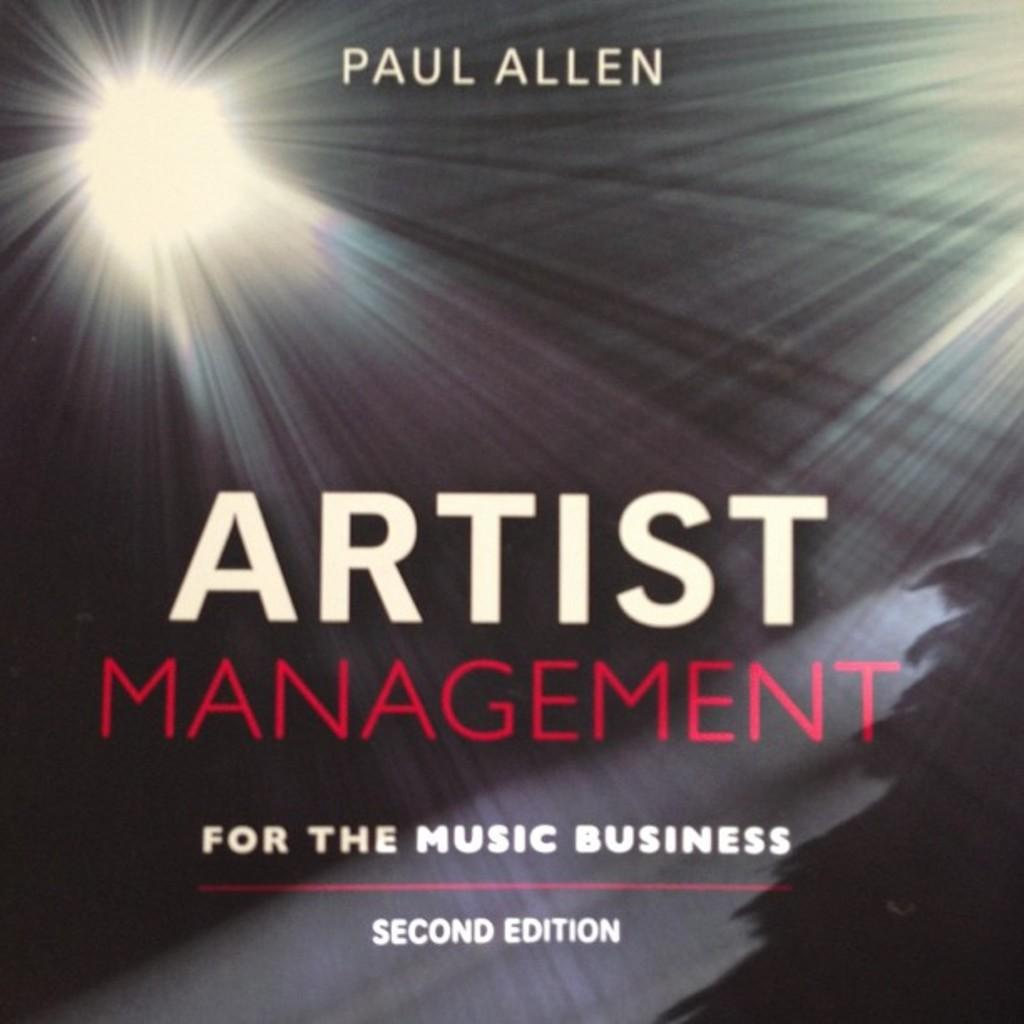Provide a one-sentence caption for the provided image. A book with colorful lights about the music business. 